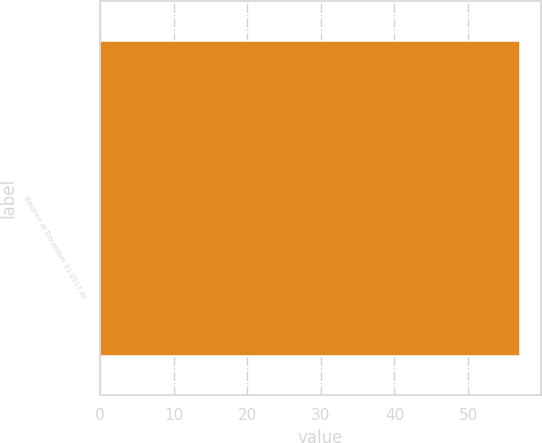Convert chart to OTSL. <chart><loc_0><loc_0><loc_500><loc_500><bar_chart><fcel>Balance at December 31 2017 as<nl><fcel>57.1<nl></chart> 